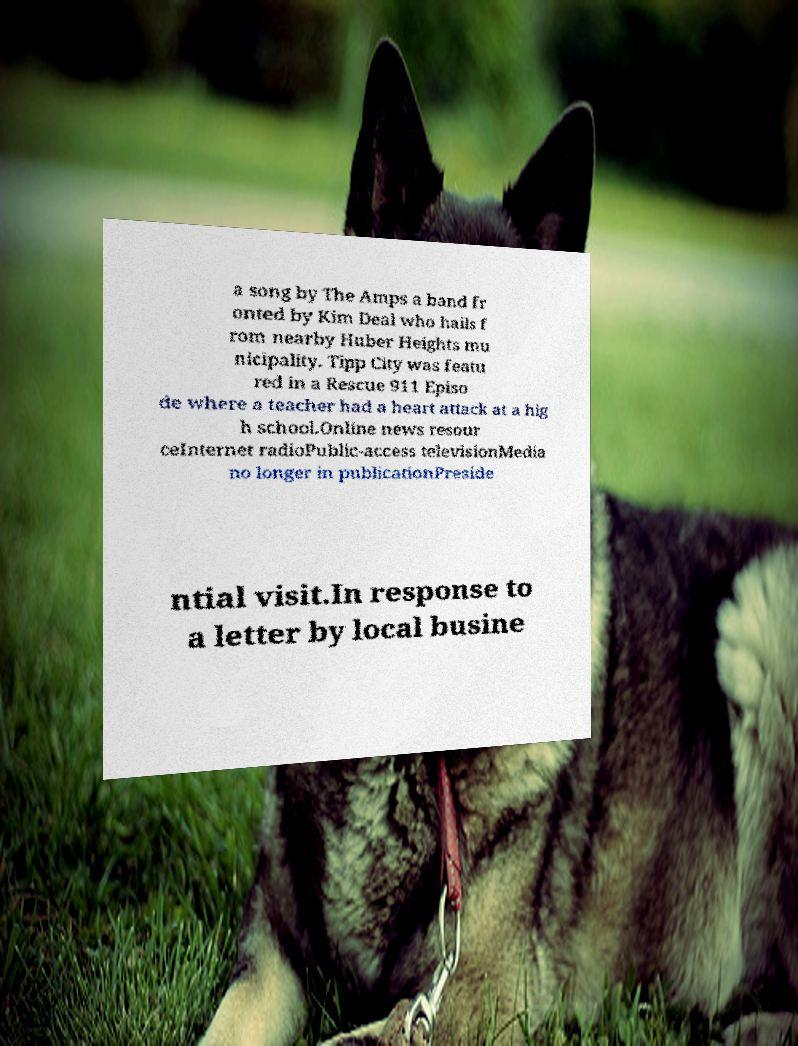Please identify and transcribe the text found in this image. a song by The Amps a band fr onted by Kim Deal who hails f rom nearby Huber Heights mu nicipality. Tipp City was featu red in a Rescue 911 Episo de where a teacher had a heart attack at a hig h school.Online news resour ceInternet radioPublic-access televisionMedia no longer in publicationPreside ntial visit.In response to a letter by local busine 